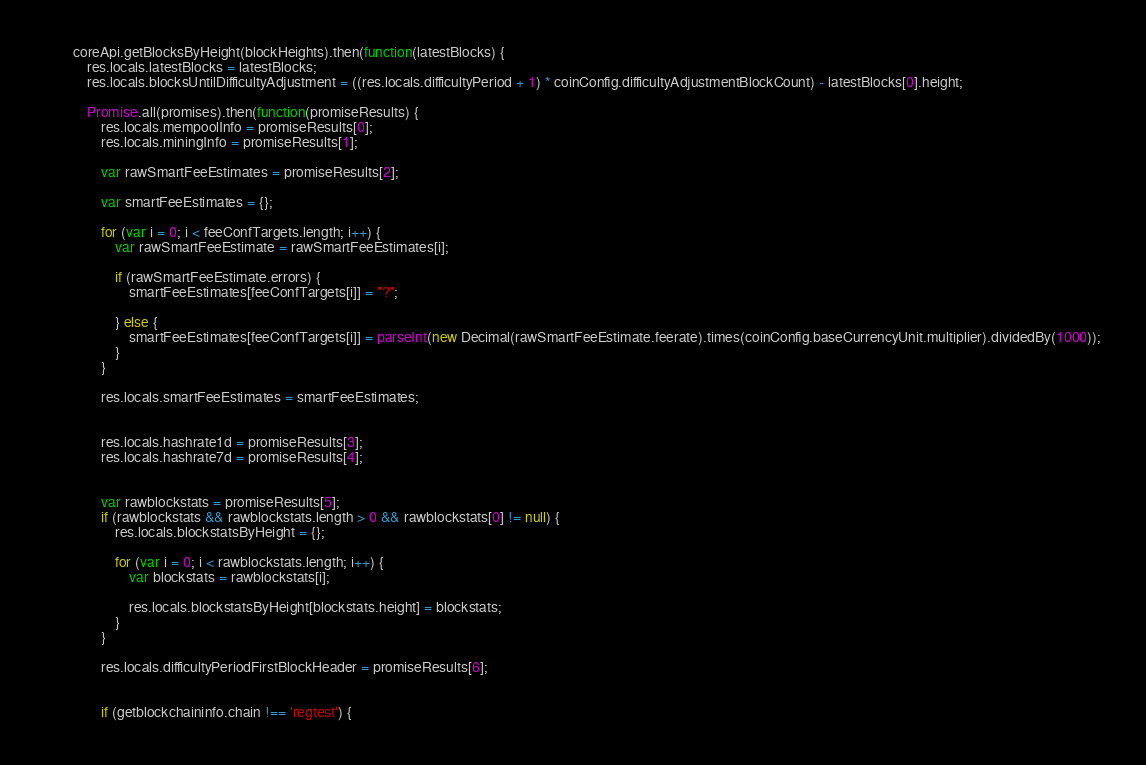<code> <loc_0><loc_0><loc_500><loc_500><_JavaScript_>
		coreApi.getBlocksByHeight(blockHeights).then(function(latestBlocks) {
			res.locals.latestBlocks = latestBlocks;
			res.locals.blocksUntilDifficultyAdjustment = ((res.locals.difficultyPeriod + 1) * coinConfig.difficultyAdjustmentBlockCount) - latestBlocks[0].height;

			Promise.all(promises).then(function(promiseResults) {
				res.locals.mempoolInfo = promiseResults[0];
				res.locals.miningInfo = promiseResults[1];

				var rawSmartFeeEstimates = promiseResults[2];

				var smartFeeEstimates = {};

				for (var i = 0; i < feeConfTargets.length; i++) {
					var rawSmartFeeEstimate = rawSmartFeeEstimates[i];

					if (rawSmartFeeEstimate.errors) {
						smartFeeEstimates[feeConfTargets[i]] = "?";

					} else {
						smartFeeEstimates[feeConfTargets[i]] = parseInt(new Decimal(rawSmartFeeEstimate.feerate).times(coinConfig.baseCurrencyUnit.multiplier).dividedBy(1000));
					}
				}

				res.locals.smartFeeEstimates = smartFeeEstimates;


				res.locals.hashrate1d = promiseResults[3];
				res.locals.hashrate7d = promiseResults[4];

				
				var rawblockstats = promiseResults[5];
				if (rawblockstats && rawblockstats.length > 0 && rawblockstats[0] != null) {
					res.locals.blockstatsByHeight = {};

					for (var i = 0; i < rawblockstats.length; i++) {
						var blockstats = rawblockstats[i];

						res.locals.blockstatsByHeight[blockstats.height] = blockstats;
					}
				}

				res.locals.difficultyPeriodFirstBlockHeader = promiseResults[6];
				

				if (getblockchaininfo.chain !== 'regtest') {</code> 